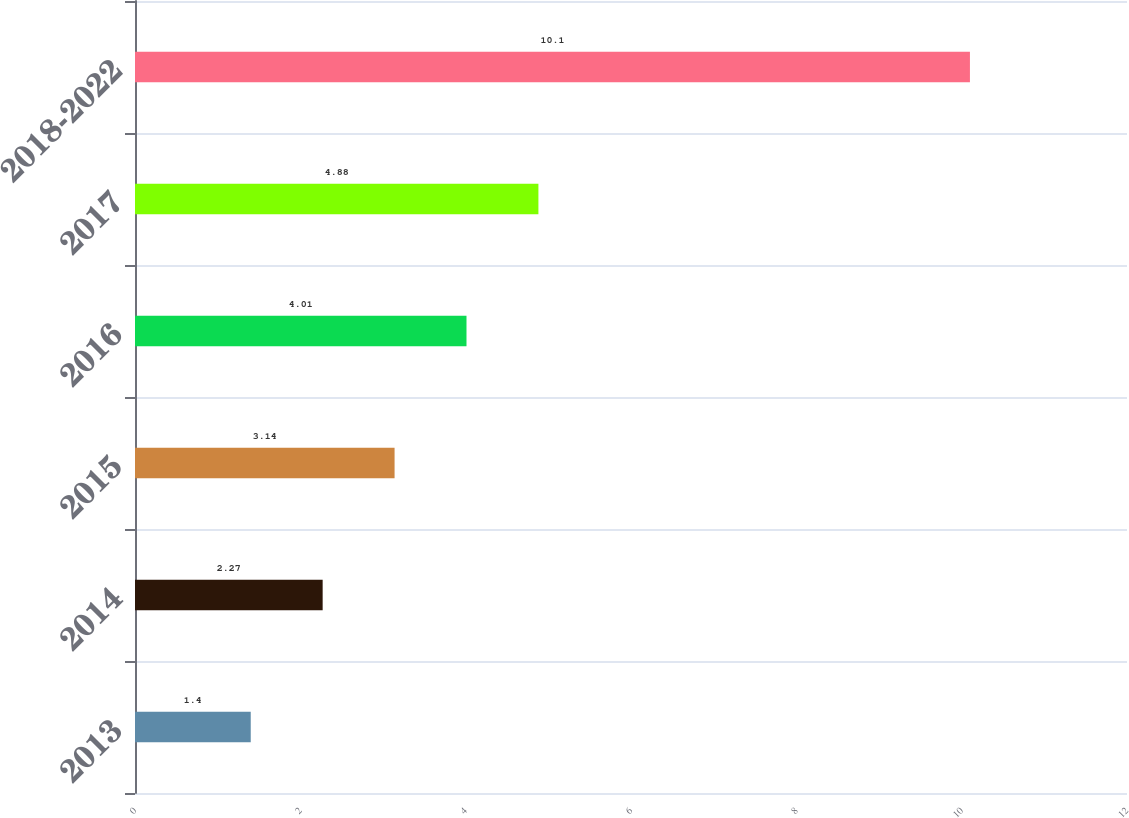Convert chart to OTSL. <chart><loc_0><loc_0><loc_500><loc_500><bar_chart><fcel>2013<fcel>2014<fcel>2015<fcel>2016<fcel>2017<fcel>2018-2022<nl><fcel>1.4<fcel>2.27<fcel>3.14<fcel>4.01<fcel>4.88<fcel>10.1<nl></chart> 